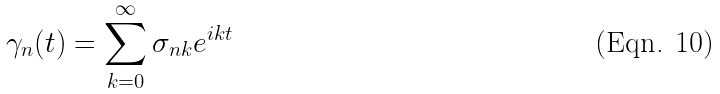<formula> <loc_0><loc_0><loc_500><loc_500>\gamma _ { n } ( t ) = \sum _ { k = 0 } ^ { \infty } \sigma _ { n k } e ^ { i k t }</formula> 